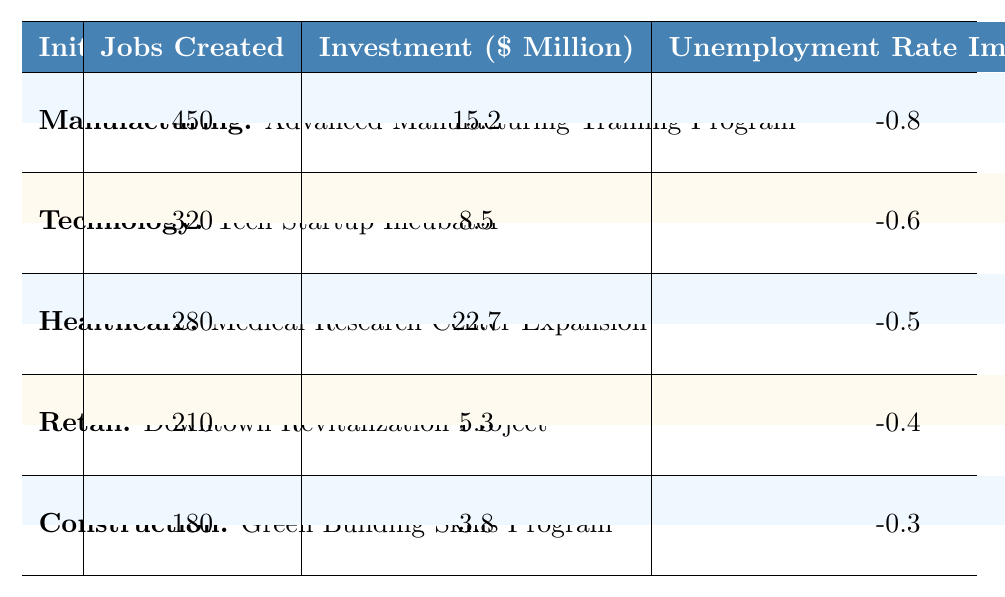What is the total number of jobs created across all initiatives? To find the total jobs created, we can sum the jobs created for each sector: 450 (Manufacturing) + 320 (Technology) + 280 (Healthcare) + 210 (Retail) + 180 (Construction) = 1440.
Answer: 1440 Which sector has the highest investment in job creation initiatives? By comparing the investment values, Healthcare has the highest investment at 22.7 million dollars.
Answer: Healthcare What is the unemployment rate impact of the Tech Startup Incubator initiative? The unemployment rate impact of the Tech Startup Incubator initiative is -0.6%.
Answer: -0.6% How many more jobs were created by the Manufacturing initiative compared to the Construction initiative? The Manufacturing initiative created 450 jobs, while the Construction initiative created 180 jobs. The difference is 450 - 180 = 270 jobs.
Answer: 270 Is the Downtown Revitalization Project more effective than the Green Building Skills Program in terms of jobs created? The Downtown Revitalization Project created 210 jobs, while the Green Building Skills Program created 180 jobs. Since 210 is greater than 180, it is more effective in job creation.
Answer: Yes What is the average unemployment rate impact for all initiatives? First, we sum the unemployment rate impacts: -0.8 + -0.6 + -0.5 + -0.4 + -0.3 = -2.6. There are 5 initiatives, so we divide -2.6 by 5 to get the average: -2.6 / 5 = -0.52%.
Answer: -0.52% How does the investment in the Medical Research Center Expansion compare to the investment in the Downtown Revitalization Project? The investment for Medical Research Center Expansion is 22.7 million, while for Downtown Revitalization it is 5.3 million. 22.7 million is significantly higher than 5.3 million.
Answer: Higher If we consider only the Manufacturing and Healthcare sectors, what is the combined impact on the unemployment rate? The combined impact involves adding the unemployment rate impacts: -0.8 (Manufacturing) + -0.5 (Healthcare) = -1.3%.
Answer: -1.3% Which sector's initiative resulted in the least number of jobs created? The Construction sector's initiative, the Green Building Skills Program, resulted in the least number of jobs created, with 180 jobs.
Answer: Construction What is the total investment in job creation initiatives for the Retail and Technology sectors combined? The total investment for Retail is 5.3 million and for Technology is 8.5 million. Together, they amount to 5.3 + 8.5 = 13.8 million dollars.
Answer: 13.8 million 